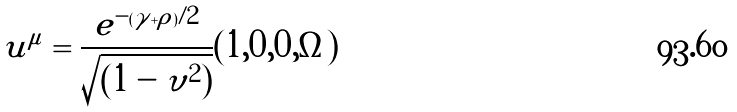Convert formula to latex. <formula><loc_0><loc_0><loc_500><loc_500>u ^ { \mu } = \frac { e ^ { - ( \gamma + \rho ) / 2 } } { \sqrt { ( 1 - \upsilon ^ { 2 } ) } } ( 1 , 0 , 0 , \Omega )</formula> 